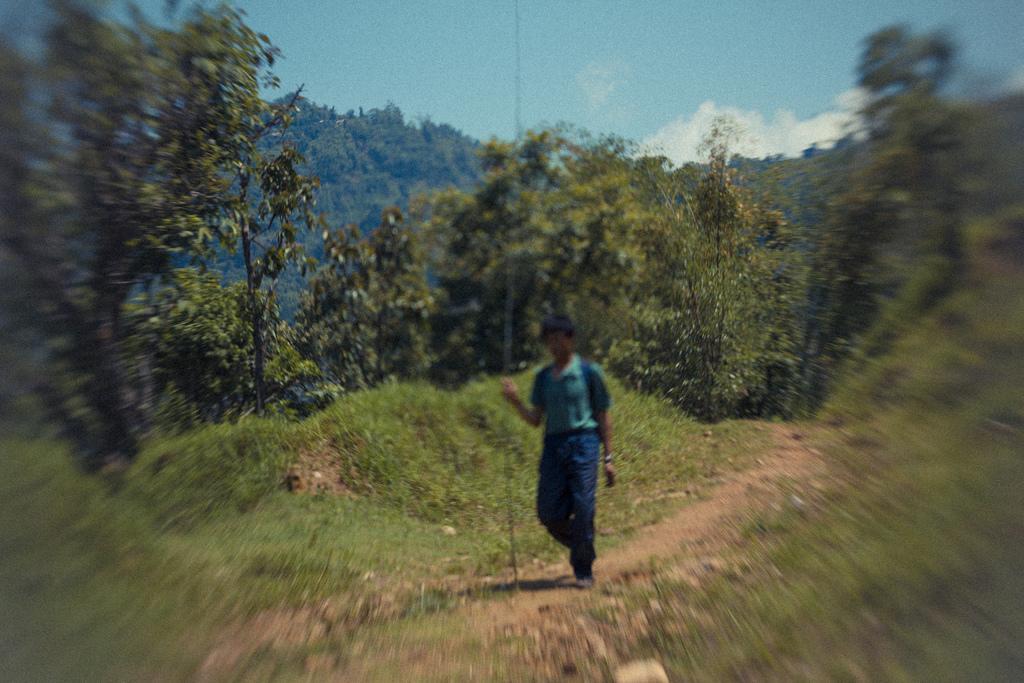Could you give a brief overview of what you see in this image? As we can see in the image there is grass, trees, a person walking over here and hills. At the top there is a sky. 